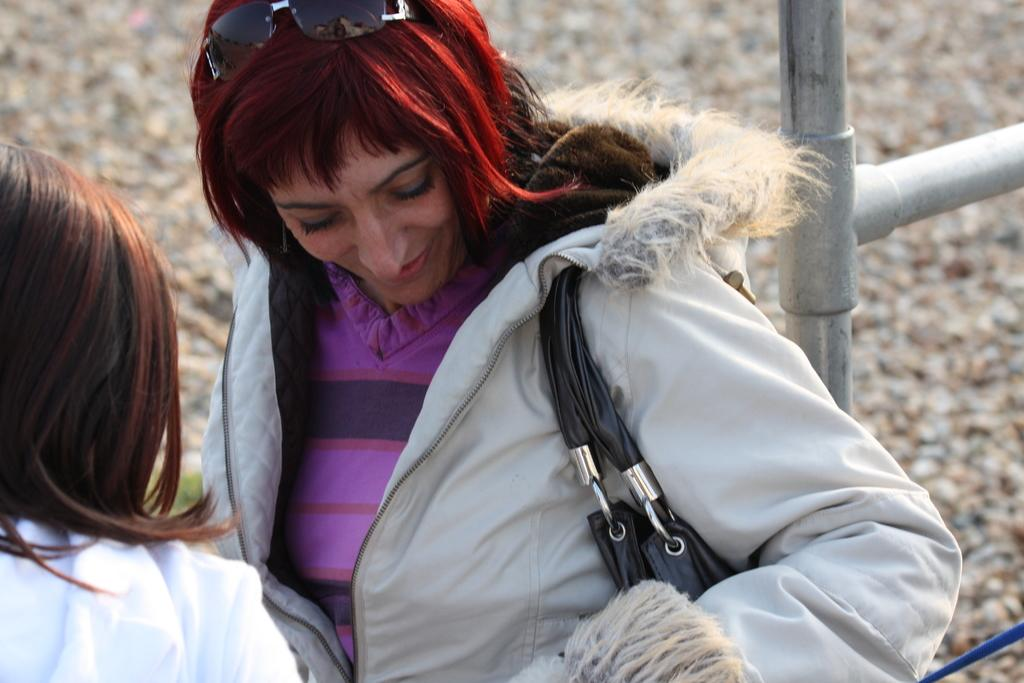How many people are in the image? There are two persons in the image. What can be seen at the back side of the image? There are marbles at the back side of the image. What object is located on the right side of the image? There is an iron rod on the right side of the image. What level of expertise does the hen have in the image? There is no hen present in the image. How does the iron rod shake in the image? The iron rod does not shake in the image; it is stationary on the right side. 